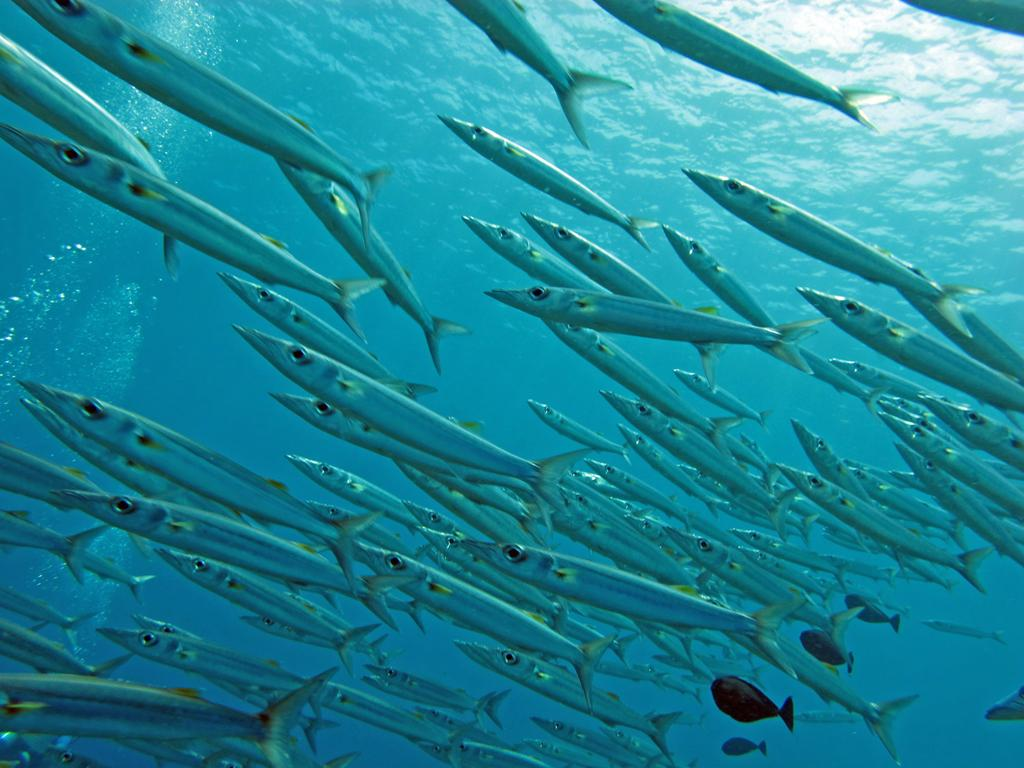What type of animals can be seen in the water in the image? There are flocks of fishes in the water. Can you describe the movement of the fishes in the image? The provided facts do not mention the movement of the fishes, so we cannot describe it. What is the primary element in which the fishes are situated? The fishes are situated in water. What type of cracker is being used to feed the fishes in the image? There is no cracker present in the image, as it only features flocks of fishes in the water. What type of work is being done by the fishes in the image? The provided facts do not mention any work being done by the fishes, so we cannot describe it. 